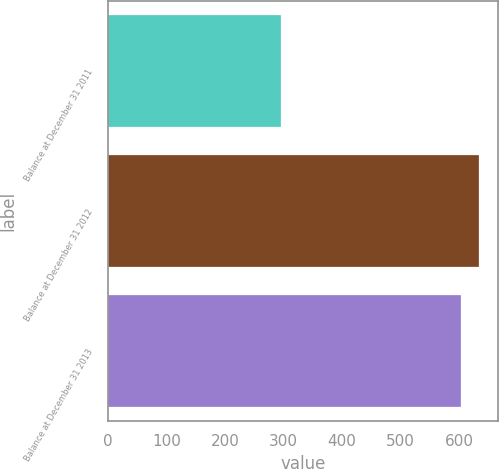Convert chart. <chart><loc_0><loc_0><loc_500><loc_500><bar_chart><fcel>Balance at December 31 2011<fcel>Balance at December 31 2012<fcel>Balance at December 31 2013<nl><fcel>296<fcel>634<fcel>603<nl></chart> 